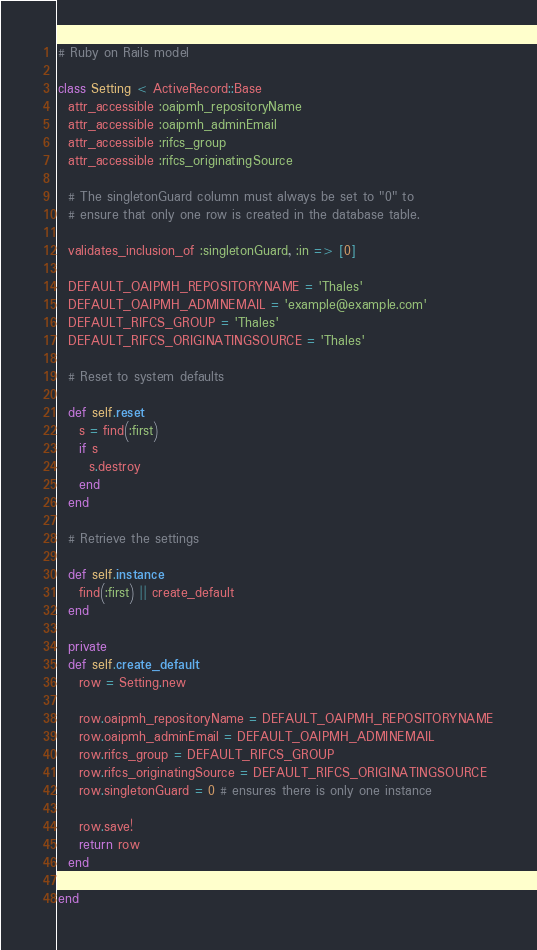Convert code to text. <code><loc_0><loc_0><loc_500><loc_500><_Ruby_># Ruby on Rails model

class Setting < ActiveRecord::Base
  attr_accessible :oaipmh_repositoryName
  attr_accessible :oaipmh_adminEmail
  attr_accessible :rifcs_group
  attr_accessible :rifcs_originatingSource

  # The singletonGuard column must always be set to "0" to
  # ensure that only one row is created in the database table.

  validates_inclusion_of :singletonGuard, :in => [0]

  DEFAULT_OAIPMH_REPOSITORYNAME = 'Thales'
  DEFAULT_OAIPMH_ADMINEMAIL = 'example@example.com'
  DEFAULT_RIFCS_GROUP = 'Thales'
  DEFAULT_RIFCS_ORIGINATINGSOURCE = 'Thales'

  # Reset to system defaults

  def self.reset
    s = find(:first)
    if s
      s.destroy
    end
  end

  # Retrieve the settings

  def self.instance
    find(:first) || create_default
  end

  private
  def self.create_default
    row = Setting.new

    row.oaipmh_repositoryName = DEFAULT_OAIPMH_REPOSITORYNAME
    row.oaipmh_adminEmail = DEFAULT_OAIPMH_ADMINEMAIL
    row.rifcs_group = DEFAULT_RIFCS_GROUP
    row.rifcs_originatingSource = DEFAULT_RIFCS_ORIGINATINGSOURCE
    row.singletonGuard = 0 # ensures there is only one instance

    row.save!
    return row
  end

end
</code> 